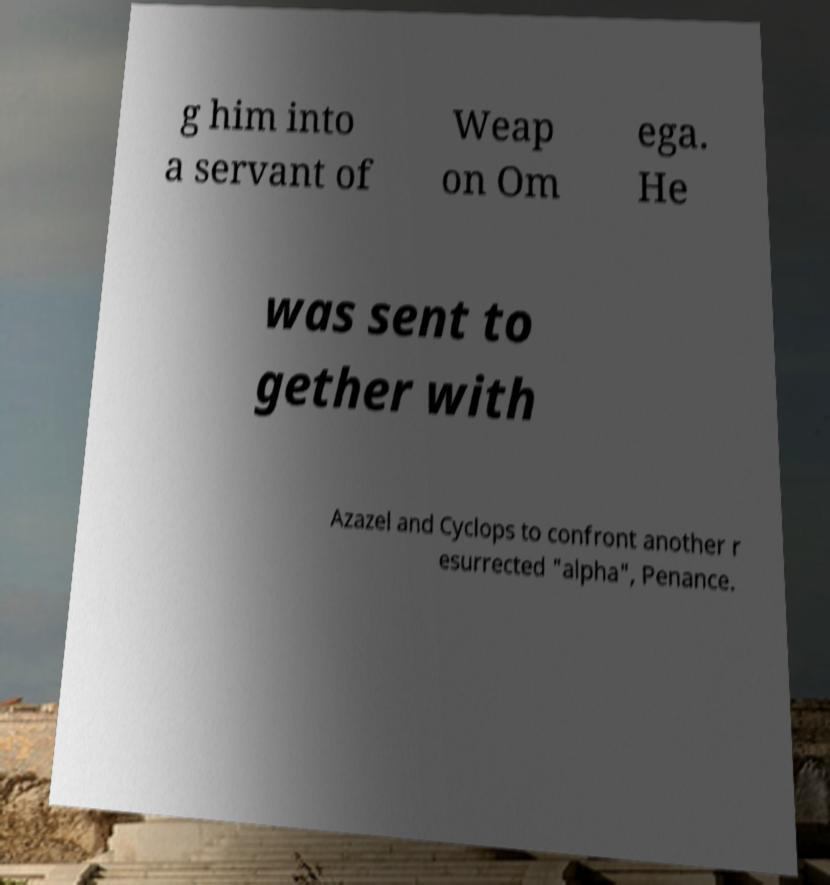There's text embedded in this image that I need extracted. Can you transcribe it verbatim? g him into a servant of Weap on Om ega. He was sent to gether with Azazel and Cyclops to confront another r esurrected "alpha", Penance. 